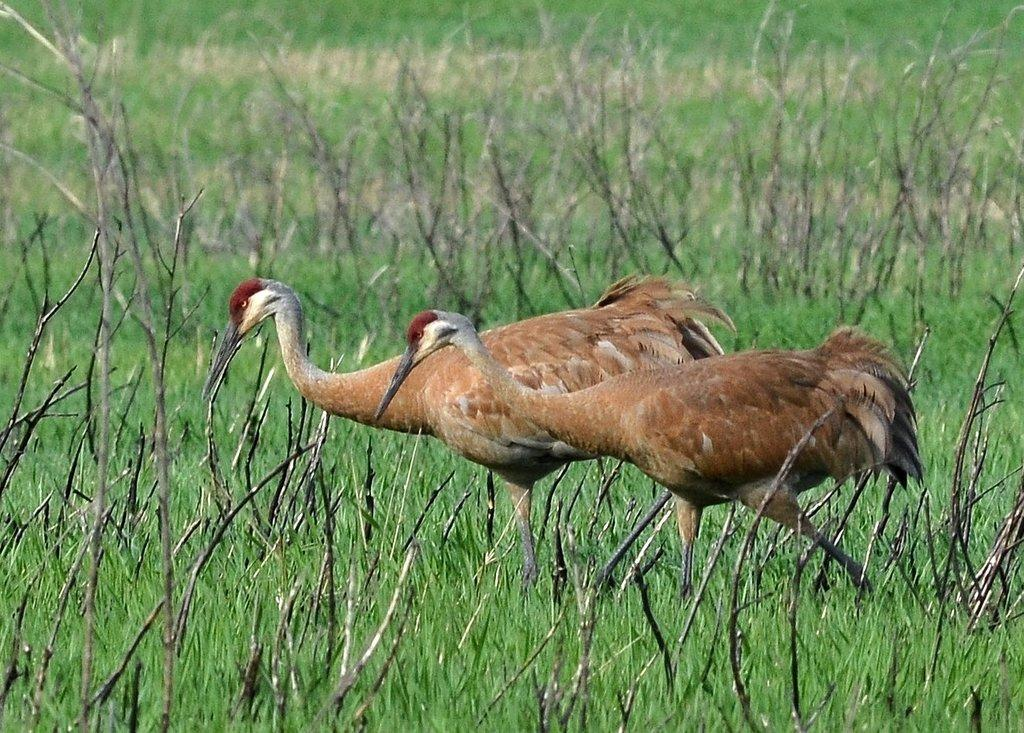What type of animals can be seen in the image? Birds can be seen in the image. What type of vegetation is present in the image? There is grass and twigs in the image. What is visible in the background of the image? The background of the image includes grass. What type of wine is being served in the image? There is no wine present in the image; it features birds, grass, and twigs. How does the image provide support for the birds? The image does not provide support for the birds; it is a static representation of the birds, grass, and twigs. 